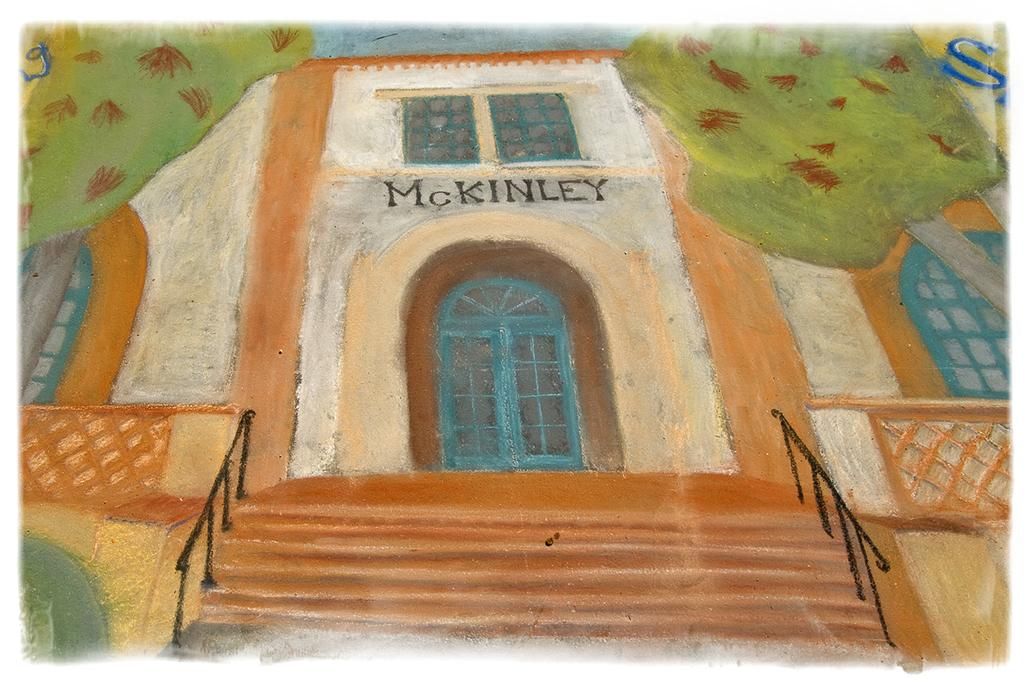What type of artwork is depicted in the image? The image is a painting. What type of structure can be seen in the painting? There is a building in the painting. Are there any architectural features present in the painting? Yes, there are stairs, doors, and railings in the painting. What type of natural elements are present in the painting? There are trees in the painting. What direction is the robin flying in the painting? There is no robin present in the painting; it only features a building, stairs, doors, railings, and trees. What type of apparatus is used to clean the windows in the painting? There is no apparatus visible in the painting for cleaning windows. 